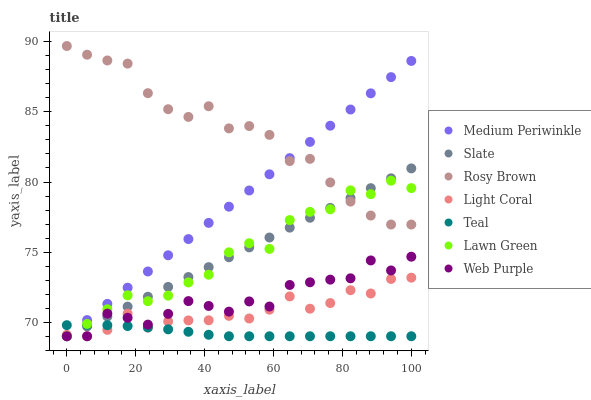Does Teal have the minimum area under the curve?
Answer yes or no. Yes. Does Rosy Brown have the maximum area under the curve?
Answer yes or no. Yes. Does Slate have the minimum area under the curve?
Answer yes or no. No. Does Slate have the maximum area under the curve?
Answer yes or no. No. Is Slate the smoothest?
Answer yes or no. Yes. Is Web Purple the roughest?
Answer yes or no. Yes. Is Rosy Brown the smoothest?
Answer yes or no. No. Is Rosy Brown the roughest?
Answer yes or no. No. Does Lawn Green have the lowest value?
Answer yes or no. Yes. Does Rosy Brown have the lowest value?
Answer yes or no. No. Does Rosy Brown have the highest value?
Answer yes or no. Yes. Does Slate have the highest value?
Answer yes or no. No. Is Web Purple less than Rosy Brown?
Answer yes or no. Yes. Is Rosy Brown greater than Teal?
Answer yes or no. Yes. Does Web Purple intersect Teal?
Answer yes or no. Yes. Is Web Purple less than Teal?
Answer yes or no. No. Is Web Purple greater than Teal?
Answer yes or no. No. Does Web Purple intersect Rosy Brown?
Answer yes or no. No. 